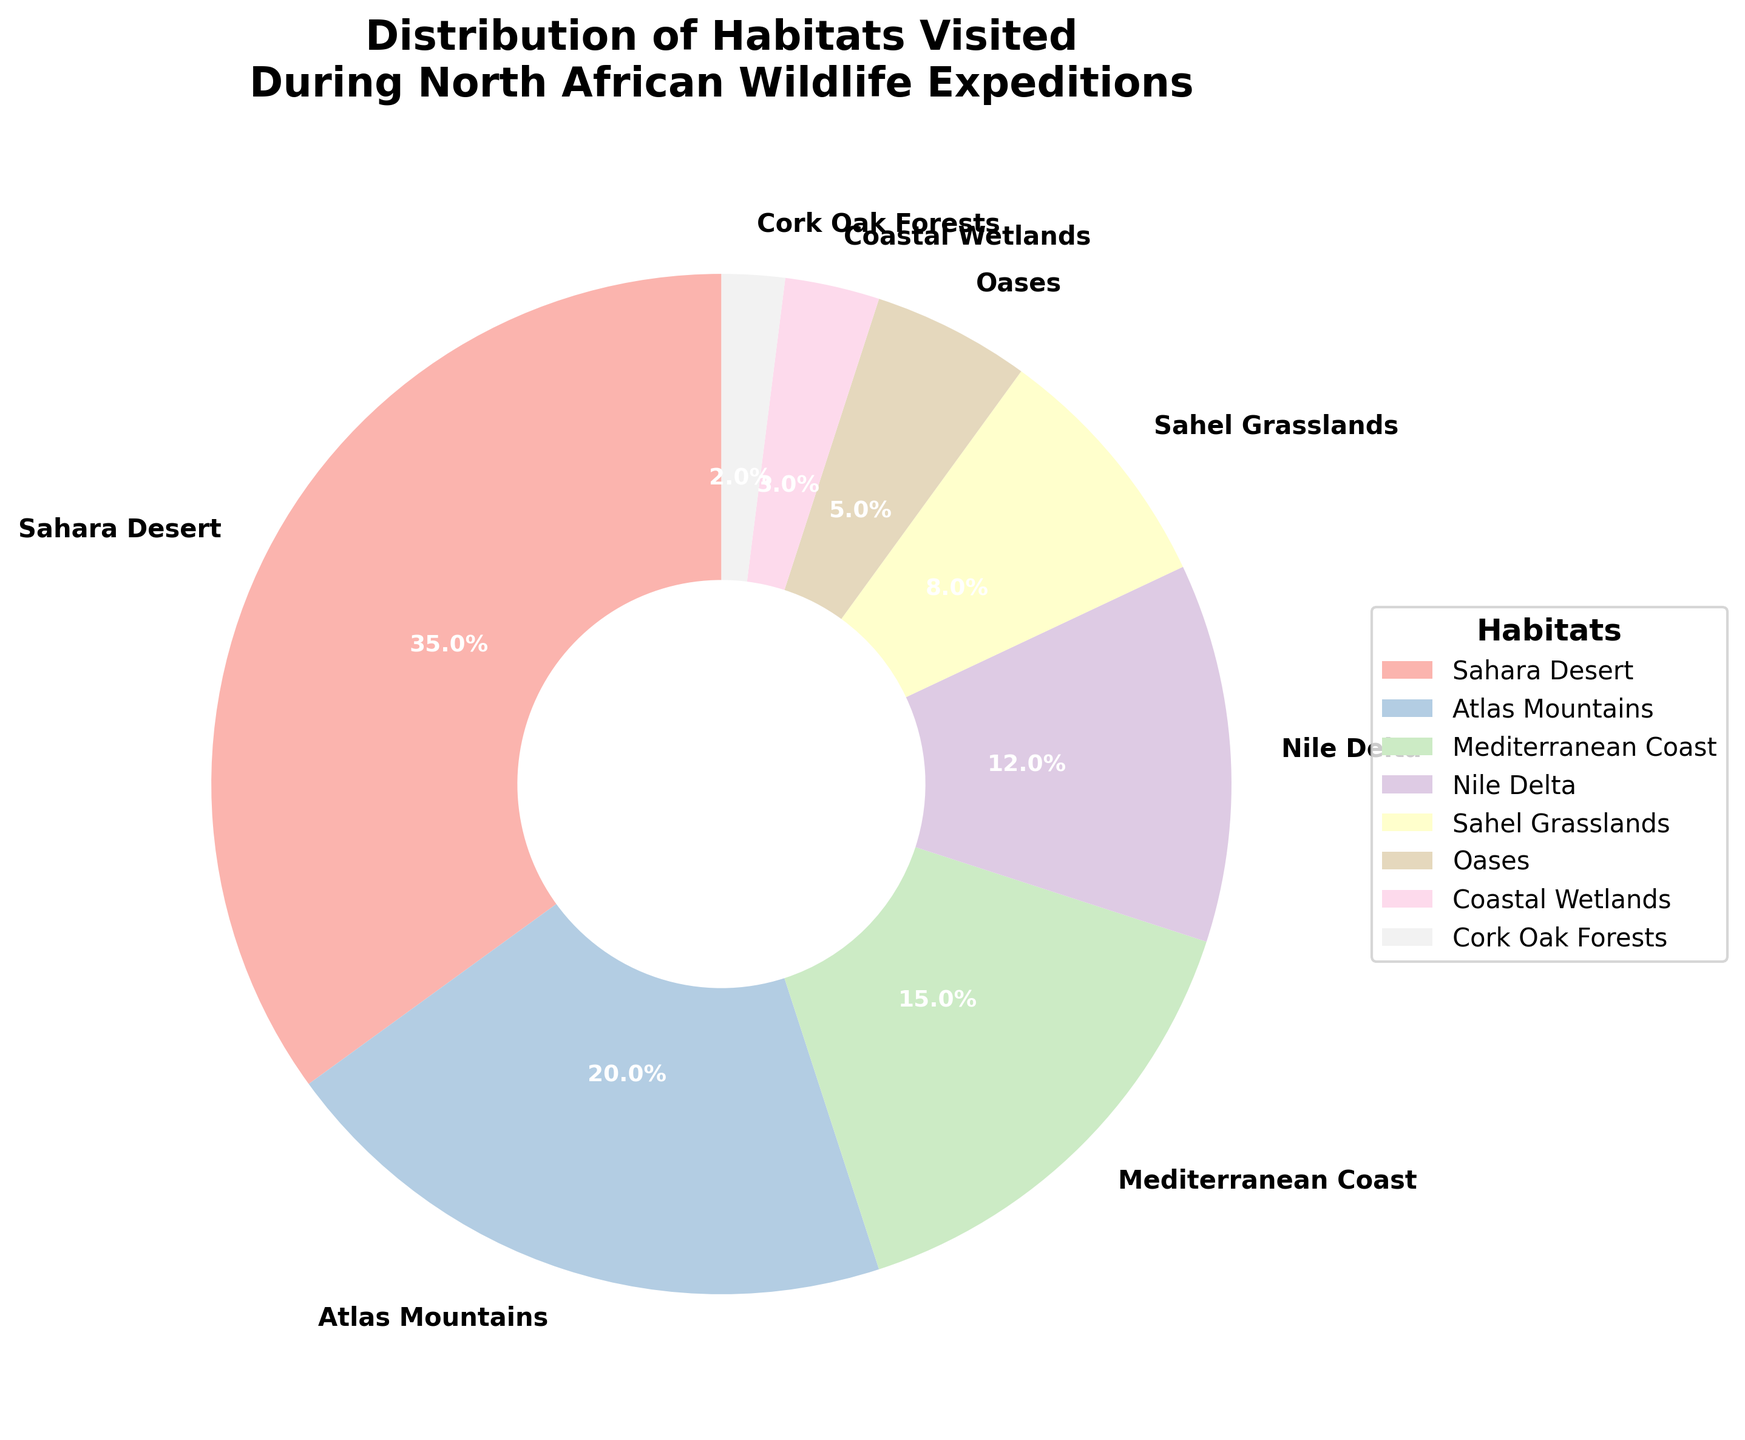What habitat has the largest percentage of visits? The pie chart shows that the Sahara Desert segment is the largest.
Answer: Sahara Desert Which habitat has a higher percentage of visits: Atlas Mountains or Oases? The pie chart indicates that the Atlas Mountains have 20% and the Oases have 5%.
Answer: Atlas Mountains What's the combined percentage of visits for the Mediterranean Coast and Nile Delta? Mediterranean Coast has 15% and Nile Delta has 12%. Adding them together gives 15% + 12%.
Answer: 27% How much more visited is the Sahara Desert compared to the Sahel Grasslands? The Sahara Desert is 35% and the Sahel Grasslands are 8%. The difference is 35% - 8%.
Answer: 27% Which two habitats are minimally visited and what is their combined percentage? Coastal Wetlands and Cork Oak Forests have the smallest segments with 3% and 2% respectively. Adding them together gives 3% + 2%.
Answer: 5% Compare the percentage of visits between the Coastal Wetlands and the Atlas Mountains. Coastal Wetlands have 3% and the Atlas Mountains have 20%. 3% is less than 20%.
Answer: Coastal Wetlands less than Atlas Mountains What is the average percentage of visits for the Sahara Desert, Sahel Grasslands, and Oases? The percentages are 35% (Sahara Desert), 8% (Sahel Grasslands), and 5% (Oases). The sum is 35% + 8% + 5% = 48%. The average is 48% / 3.
Answer: 16% By how many percentage points does the Mediterranean Coast exceed the visits to Cork Oak Forests? Mediterranean Coast has 15% and Cork Oak Forests have 2%. The difference is 15% - 2%.
Answer: 13% 